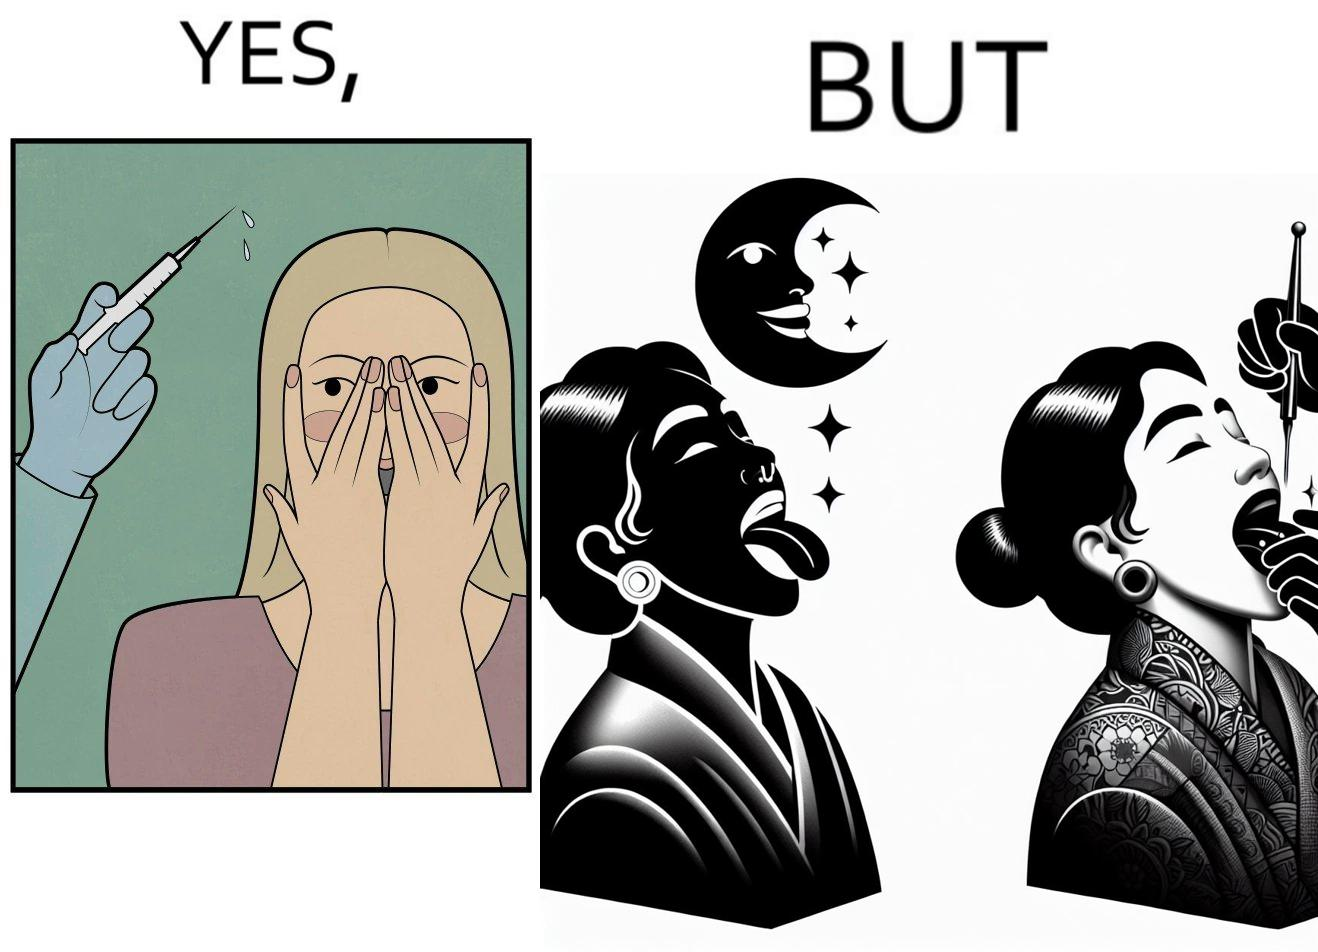Is this image satirical or non-satirical? Yes, this image is satirical. 